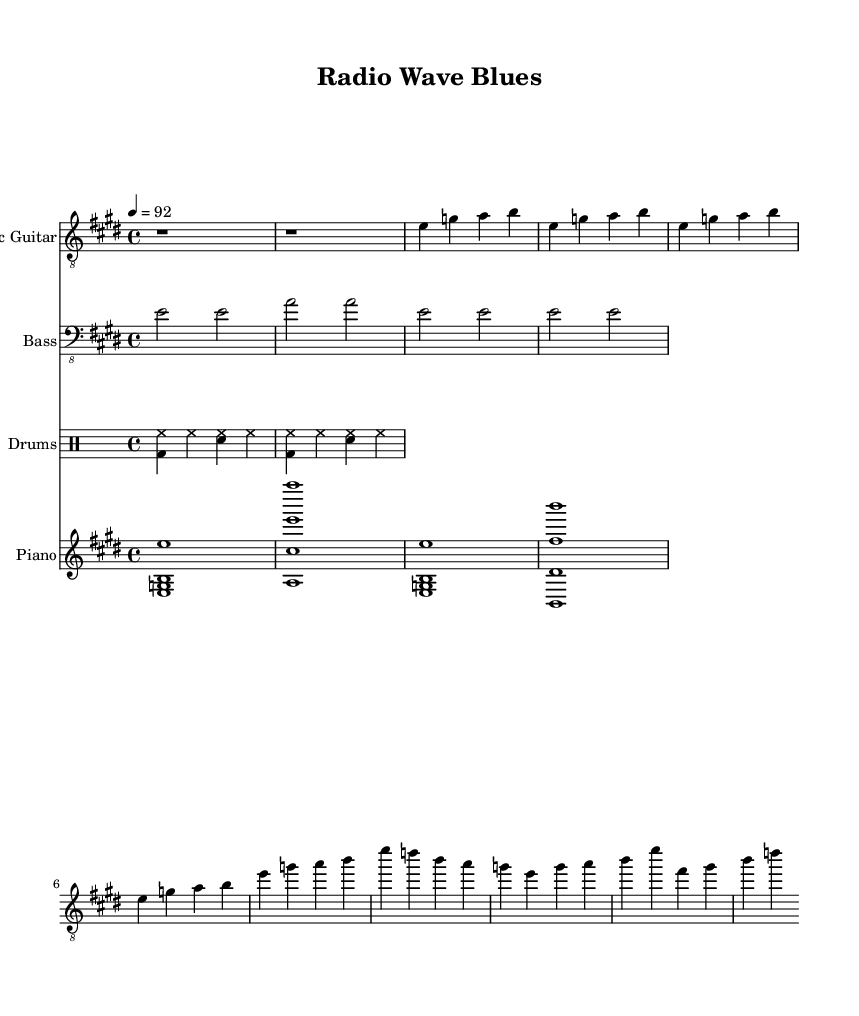What is the key signature of this music? The key signature is E major, which has four sharps (F#, C#, G#, D#).
Answer: E major What is the time signature of this music? The time signature shown is 4/4, meaning there are four beats in each measure and the quarter note gets one beat.
Answer: 4/4 What is the tempo marking for this piece? The tempo marking is 92 beats per minute, indicating the speed at which the music should be played.
Answer: 92 Which instrument part includes a basic drum pattern? The drums part includes a basic drum pattern. It uses kick drum (bd), snare (sn), and hi-hat (hh).
Answer: Drums How many measures are there in the verse? The verse section contains 4 measures, each represented by a vertical bar line in the music.
Answer: 4 What is the primary chord played by the piano in the intro? The primary chord played by the piano in the intro is E major, which consists of the notes E, G#, and B.
Answer: E major What rhythmic feel is common in Electric Blues as represented in this piece? The rhythmic feel in Electric Blues typically includes a shuffle or swing feel, as commonly found in the use of syncopation and accented off-beats, though the rhythm here may be more straightforward.
Answer: Swing 